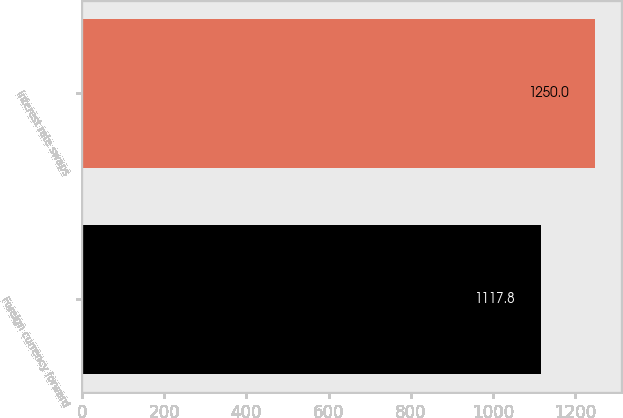Convert chart. <chart><loc_0><loc_0><loc_500><loc_500><bar_chart><fcel>Foreign currency forward<fcel>Interest rate swaps<nl><fcel>1117.8<fcel>1250<nl></chart> 